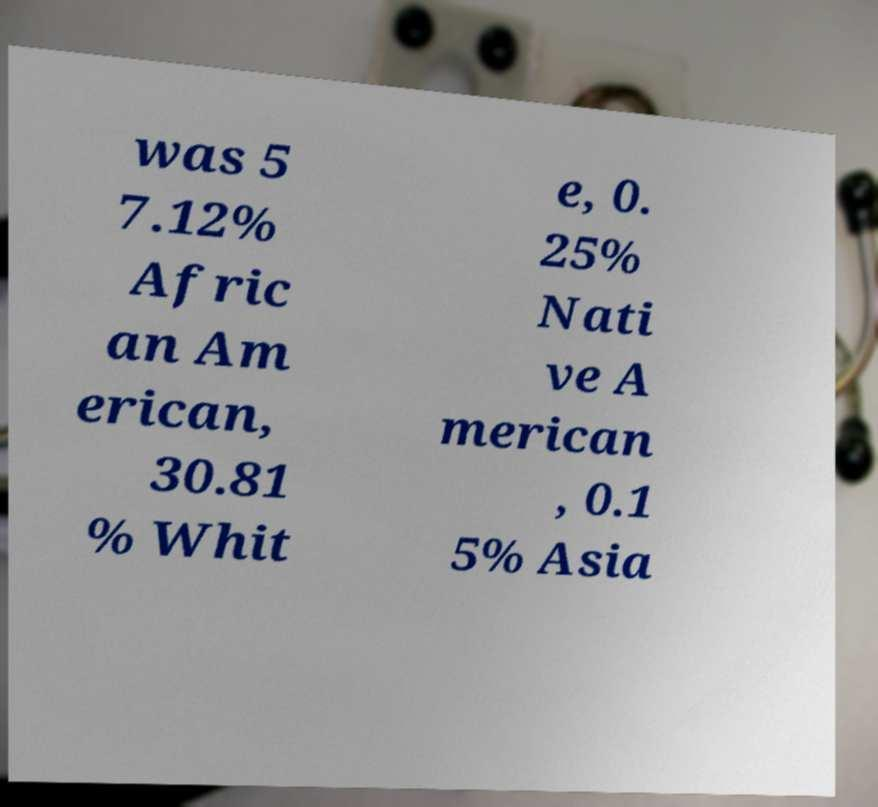Can you read and provide the text displayed in the image?This photo seems to have some interesting text. Can you extract and type it out for me? was 5 7.12% Afric an Am erican, 30.81 % Whit e, 0. 25% Nati ve A merican , 0.1 5% Asia 